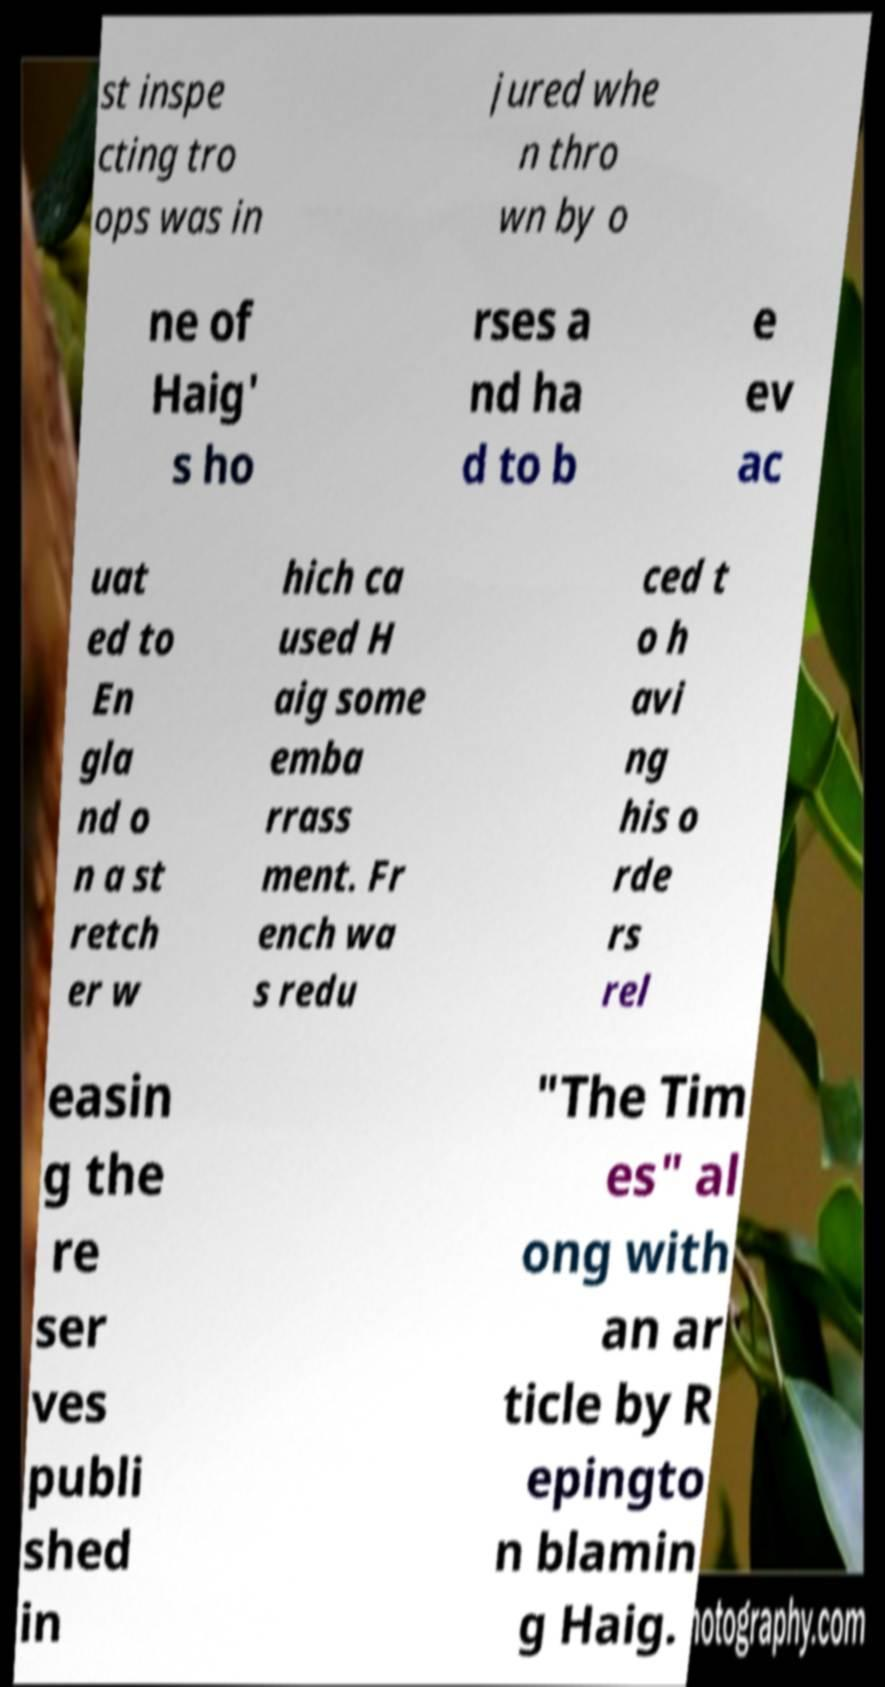For documentation purposes, I need the text within this image transcribed. Could you provide that? st inspe cting tro ops was in jured whe n thro wn by o ne of Haig' s ho rses a nd ha d to b e ev ac uat ed to En gla nd o n a st retch er w hich ca used H aig some emba rrass ment. Fr ench wa s redu ced t o h avi ng his o rde rs rel easin g the re ser ves publi shed in "The Tim es" al ong with an ar ticle by R epingto n blamin g Haig. 